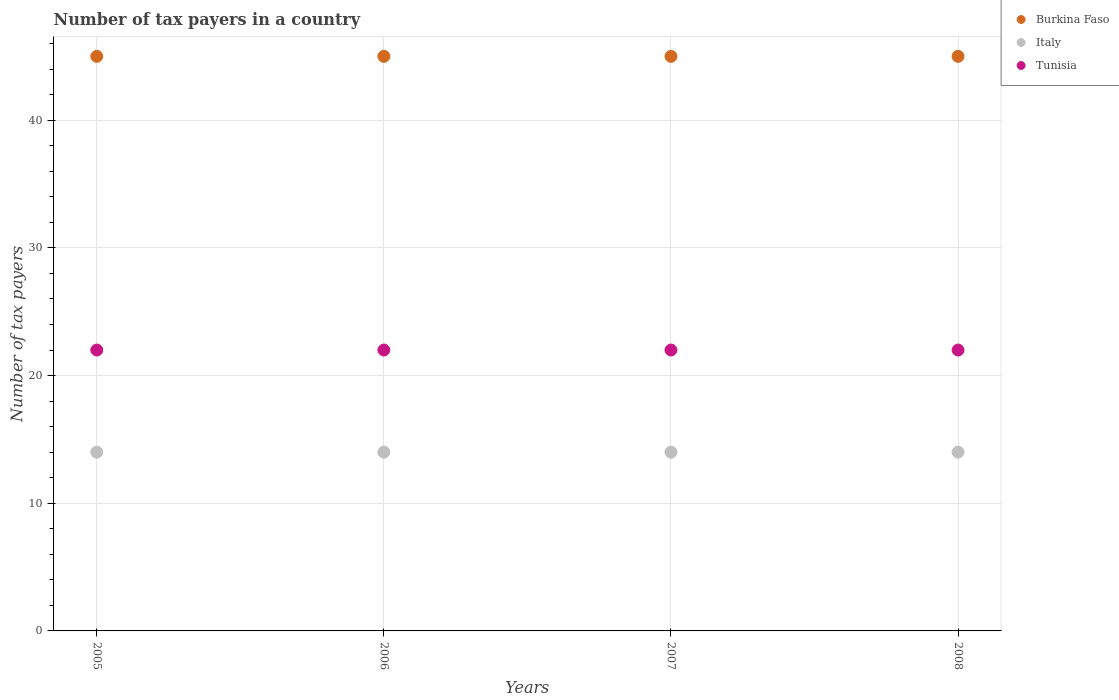How many different coloured dotlines are there?
Offer a very short reply. 3. What is the number of tax payers in in Tunisia in 2005?
Give a very brief answer. 22. Across all years, what is the maximum number of tax payers in in Tunisia?
Provide a short and direct response. 22. Across all years, what is the minimum number of tax payers in in Italy?
Offer a terse response. 14. In which year was the number of tax payers in in Italy maximum?
Offer a terse response. 2005. In which year was the number of tax payers in in Italy minimum?
Ensure brevity in your answer.  2005. What is the total number of tax payers in in Italy in the graph?
Provide a short and direct response. 56. What is the difference between the number of tax payers in in Tunisia in 2006 and that in 2008?
Ensure brevity in your answer.  0. What is the difference between the number of tax payers in in Burkina Faso in 2005 and the number of tax payers in in Tunisia in 2007?
Make the answer very short. 23. In the year 2007, what is the difference between the number of tax payers in in Burkina Faso and number of tax payers in in Tunisia?
Make the answer very short. 23. In how many years, is the number of tax payers in in Burkina Faso greater than 4?
Your response must be concise. 4. What is the ratio of the number of tax payers in in Burkina Faso in 2005 to that in 2006?
Offer a terse response. 1. Is the number of tax payers in in Burkina Faso in 2006 less than that in 2008?
Ensure brevity in your answer.  No. Is the difference between the number of tax payers in in Burkina Faso in 2005 and 2006 greater than the difference between the number of tax payers in in Tunisia in 2005 and 2006?
Provide a short and direct response. No. What is the difference between the highest and the lowest number of tax payers in in Italy?
Your answer should be very brief. 0. Does the number of tax payers in in Italy monotonically increase over the years?
Your response must be concise. No. Is the number of tax payers in in Tunisia strictly less than the number of tax payers in in Italy over the years?
Make the answer very short. No. How many years are there in the graph?
Your answer should be compact. 4. Does the graph contain any zero values?
Give a very brief answer. No. How are the legend labels stacked?
Provide a short and direct response. Vertical. What is the title of the graph?
Give a very brief answer. Number of tax payers in a country. Does "Egypt, Arab Rep." appear as one of the legend labels in the graph?
Give a very brief answer. No. What is the label or title of the Y-axis?
Ensure brevity in your answer.  Number of tax payers. What is the Number of tax payers of Italy in 2005?
Give a very brief answer. 14. What is the Number of tax payers in Burkina Faso in 2006?
Ensure brevity in your answer.  45. What is the Number of tax payers of Burkina Faso in 2007?
Provide a succinct answer. 45. What is the Number of tax payers in Italy in 2007?
Offer a terse response. 14. What is the Number of tax payers of Tunisia in 2007?
Your answer should be compact. 22. What is the Number of tax payers in Burkina Faso in 2008?
Offer a very short reply. 45. What is the Number of tax payers in Italy in 2008?
Give a very brief answer. 14. Across all years, what is the maximum Number of tax payers of Tunisia?
Provide a succinct answer. 22. What is the total Number of tax payers in Burkina Faso in the graph?
Your answer should be compact. 180. What is the total Number of tax payers of Italy in the graph?
Give a very brief answer. 56. What is the total Number of tax payers in Tunisia in the graph?
Your response must be concise. 88. What is the difference between the Number of tax payers in Burkina Faso in 2005 and that in 2006?
Keep it short and to the point. 0. What is the difference between the Number of tax payers in Burkina Faso in 2005 and that in 2007?
Your answer should be very brief. 0. What is the difference between the Number of tax payers in Tunisia in 2005 and that in 2007?
Give a very brief answer. 0. What is the difference between the Number of tax payers in Italy in 2005 and that in 2008?
Offer a very short reply. 0. What is the difference between the Number of tax payers of Tunisia in 2005 and that in 2008?
Make the answer very short. 0. What is the difference between the Number of tax payers of Burkina Faso in 2006 and that in 2007?
Offer a terse response. 0. What is the difference between the Number of tax payers in Burkina Faso in 2006 and that in 2008?
Keep it short and to the point. 0. What is the difference between the Number of tax payers in Italy in 2006 and that in 2008?
Offer a terse response. 0. What is the difference between the Number of tax payers in Tunisia in 2006 and that in 2008?
Keep it short and to the point. 0. What is the difference between the Number of tax payers of Burkina Faso in 2007 and that in 2008?
Give a very brief answer. 0. What is the difference between the Number of tax payers of Italy in 2007 and that in 2008?
Make the answer very short. 0. What is the difference between the Number of tax payers of Tunisia in 2007 and that in 2008?
Offer a terse response. 0. What is the difference between the Number of tax payers of Burkina Faso in 2005 and the Number of tax payers of Italy in 2006?
Make the answer very short. 31. What is the difference between the Number of tax payers of Burkina Faso in 2005 and the Number of tax payers of Tunisia in 2006?
Offer a terse response. 23. What is the difference between the Number of tax payers in Burkina Faso in 2005 and the Number of tax payers in Italy in 2007?
Give a very brief answer. 31. What is the difference between the Number of tax payers of Italy in 2005 and the Number of tax payers of Tunisia in 2007?
Your answer should be compact. -8. What is the difference between the Number of tax payers in Burkina Faso in 2005 and the Number of tax payers in Italy in 2008?
Provide a short and direct response. 31. What is the difference between the Number of tax payers of Burkina Faso in 2005 and the Number of tax payers of Tunisia in 2008?
Give a very brief answer. 23. What is the difference between the Number of tax payers in Burkina Faso in 2006 and the Number of tax payers in Italy in 2007?
Offer a terse response. 31. What is the difference between the Number of tax payers in Italy in 2006 and the Number of tax payers in Tunisia in 2008?
Provide a short and direct response. -8. What is the difference between the Number of tax payers in Burkina Faso in 2007 and the Number of tax payers in Tunisia in 2008?
Offer a very short reply. 23. What is the difference between the Number of tax payers of Italy in 2007 and the Number of tax payers of Tunisia in 2008?
Keep it short and to the point. -8. What is the average Number of tax payers of Italy per year?
Provide a short and direct response. 14. In the year 2005, what is the difference between the Number of tax payers of Burkina Faso and Number of tax payers of Italy?
Provide a succinct answer. 31. In the year 2005, what is the difference between the Number of tax payers of Italy and Number of tax payers of Tunisia?
Ensure brevity in your answer.  -8. In the year 2006, what is the difference between the Number of tax payers in Burkina Faso and Number of tax payers in Italy?
Offer a very short reply. 31. In the year 2006, what is the difference between the Number of tax payers in Burkina Faso and Number of tax payers in Tunisia?
Provide a succinct answer. 23. In the year 2006, what is the difference between the Number of tax payers in Italy and Number of tax payers in Tunisia?
Your response must be concise. -8. In the year 2007, what is the difference between the Number of tax payers in Burkina Faso and Number of tax payers in Italy?
Your answer should be compact. 31. In the year 2008, what is the difference between the Number of tax payers of Burkina Faso and Number of tax payers of Tunisia?
Provide a short and direct response. 23. What is the ratio of the Number of tax payers in Italy in 2005 to that in 2006?
Keep it short and to the point. 1. What is the ratio of the Number of tax payers in Italy in 2005 to that in 2008?
Your answer should be compact. 1. What is the ratio of the Number of tax payers of Burkina Faso in 2006 to that in 2007?
Provide a short and direct response. 1. What is the ratio of the Number of tax payers in Italy in 2006 to that in 2007?
Ensure brevity in your answer.  1. What is the ratio of the Number of tax payers of Burkina Faso in 2006 to that in 2008?
Your response must be concise. 1. What is the ratio of the Number of tax payers in Italy in 2006 to that in 2008?
Your response must be concise. 1. What is the difference between the highest and the second highest Number of tax payers of Tunisia?
Keep it short and to the point. 0. 